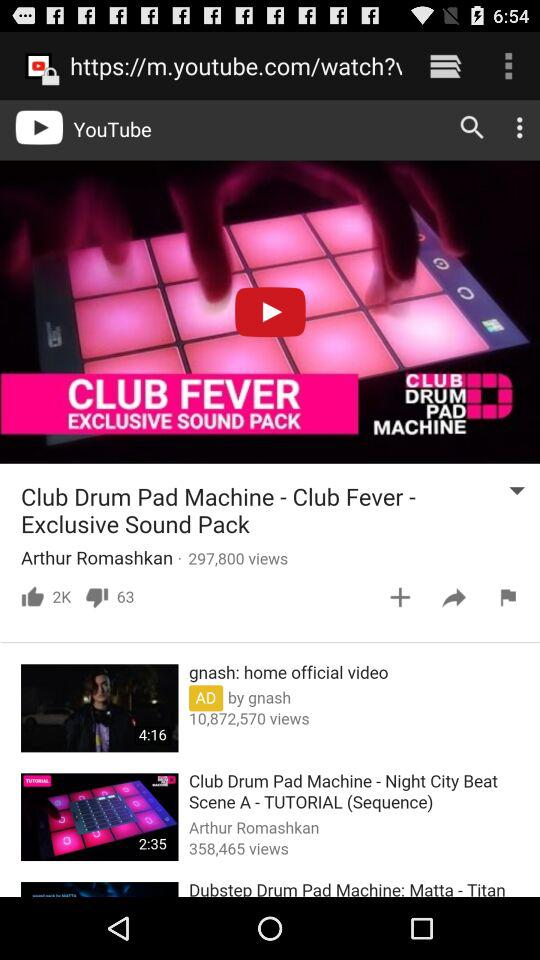What is the duration of the "gnash: home official video"? The duration of the "gnash: home official video" is 4 minutes 16 seconds. 